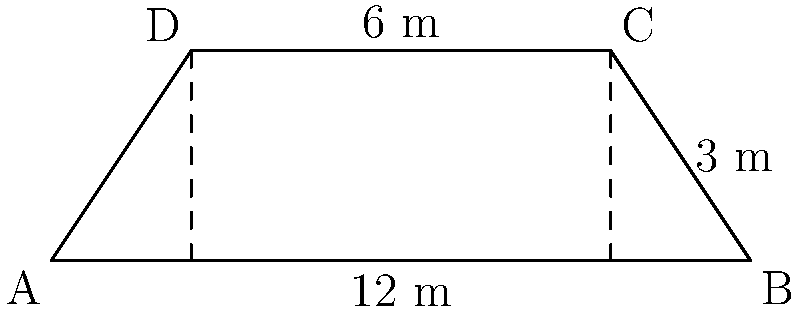The village elder shows you a unique trapezoidal bridge deck spanning a ravine. The bridge's lower base measures 12 meters, its upper base is 6 meters, and its height is 3 meters. What is the total area of the bridge deck in square meters? To find the area of the trapezoidal bridge deck, we'll use the formula for the area of a trapezoid:

$$A = \frac{1}{2}(b_1 + b_2)h$$

Where:
$A$ = Area
$b_1$ = Length of the lower base
$b_2$ = Length of the upper base
$h$ = Height of the trapezoid

Given:
$b_1 = 12$ meters (lower base)
$b_2 = 6$ meters (upper base)
$h = 3$ meters (height)

Let's substitute these values into the formula:

$$A = \frac{1}{2}(12 + 6) \times 3$$

$$A = \frac{1}{2}(18) \times 3$$

$$A = 9 \times 3$$

$$A = 27$$

Therefore, the area of the trapezoidal bridge deck is 27 square meters.
Answer: 27 m² 